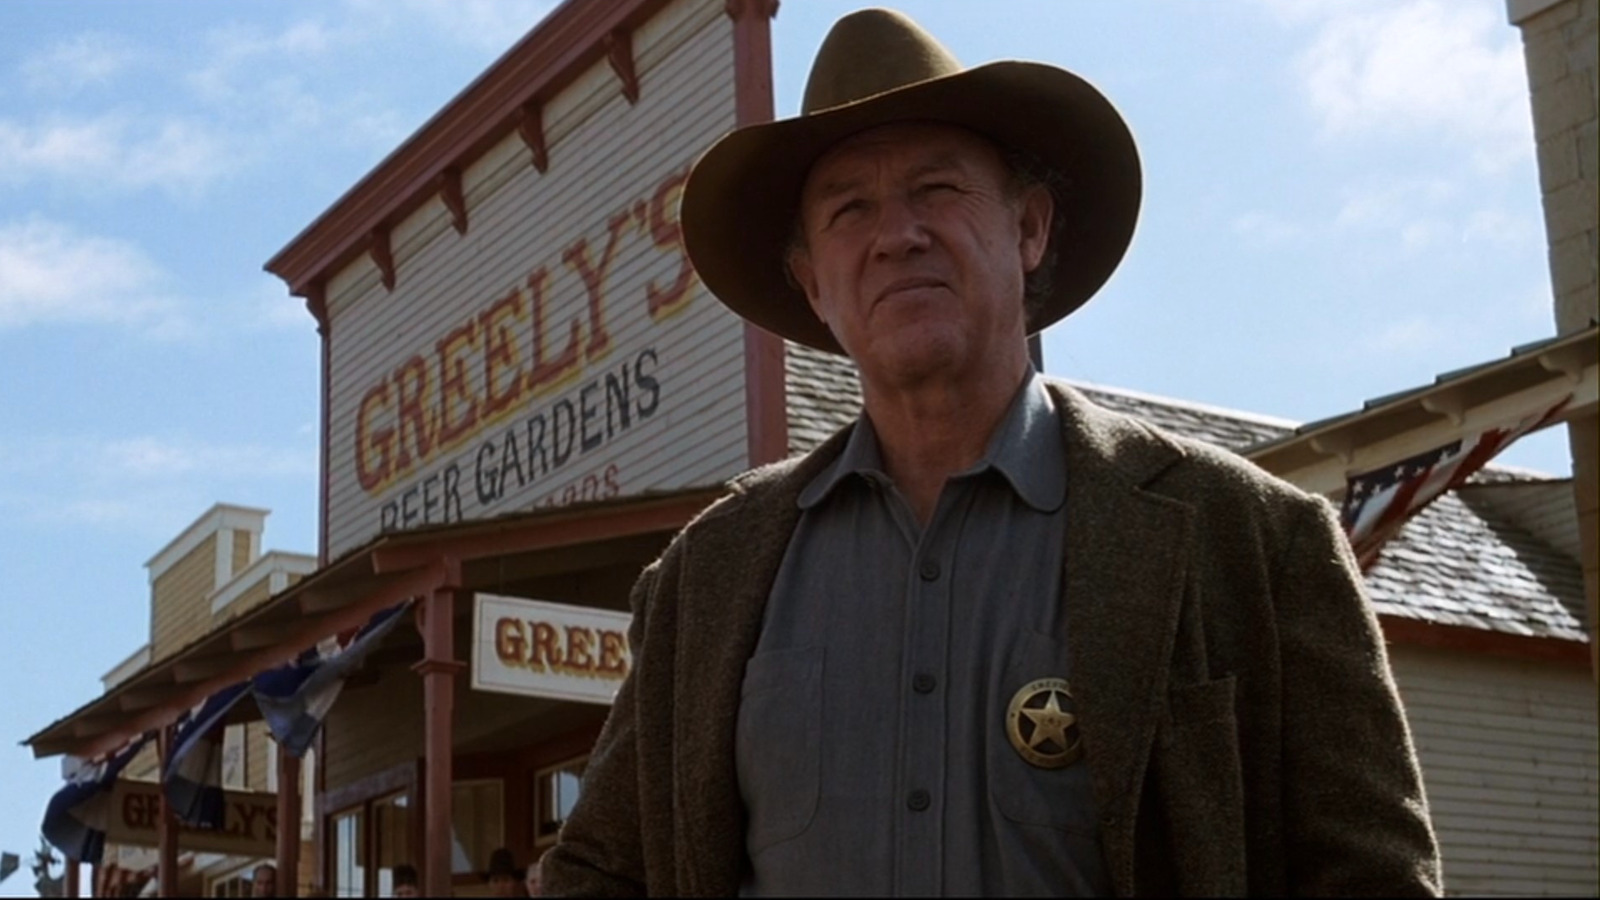What detailed preparations might the sheriff have done before stepping out of the building? Before stepping out of 'Greeley's Beer Gardens,' Sheriff Greeley took meticulous care in preparing himself for whatever awaited outside. He checked his sidearm, ensuring it was fully loaded. Next, he fastened his sturdy leather belt, ensuring his holster was secure. Pulling on his well-worn boots, he tied the laces with precision, then pulled his gray jacket over his shirt, shrugging his broad shoulders to settle it into place. Taking his brown cowboy hat off the peg, he brushed a hand over its brim before placing it firmly on his head. Lastly, the sheriff pinned his polished gold badge over his heart, a symbol of his duty and resolve. With a deep breath, he glanced around the room at familiar faces, offering a nod of reassurance before stepping out into the sunlight, prepared to face whatever challenges the day might bring. 